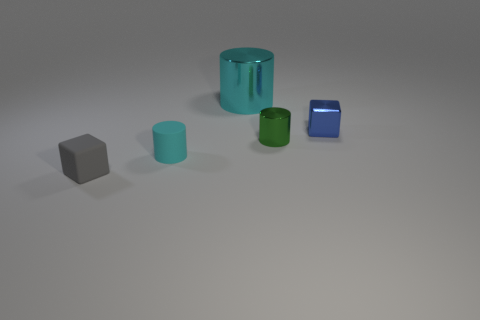Add 3 small metallic things. How many objects exist? 8 Subtract all cylinders. How many objects are left? 2 Subtract all big cyan matte balls. Subtract all green metallic cylinders. How many objects are left? 4 Add 1 tiny blue cubes. How many tiny blue cubes are left? 2 Add 4 brown rubber cylinders. How many brown rubber cylinders exist? 4 Subtract 0 cyan balls. How many objects are left? 5 